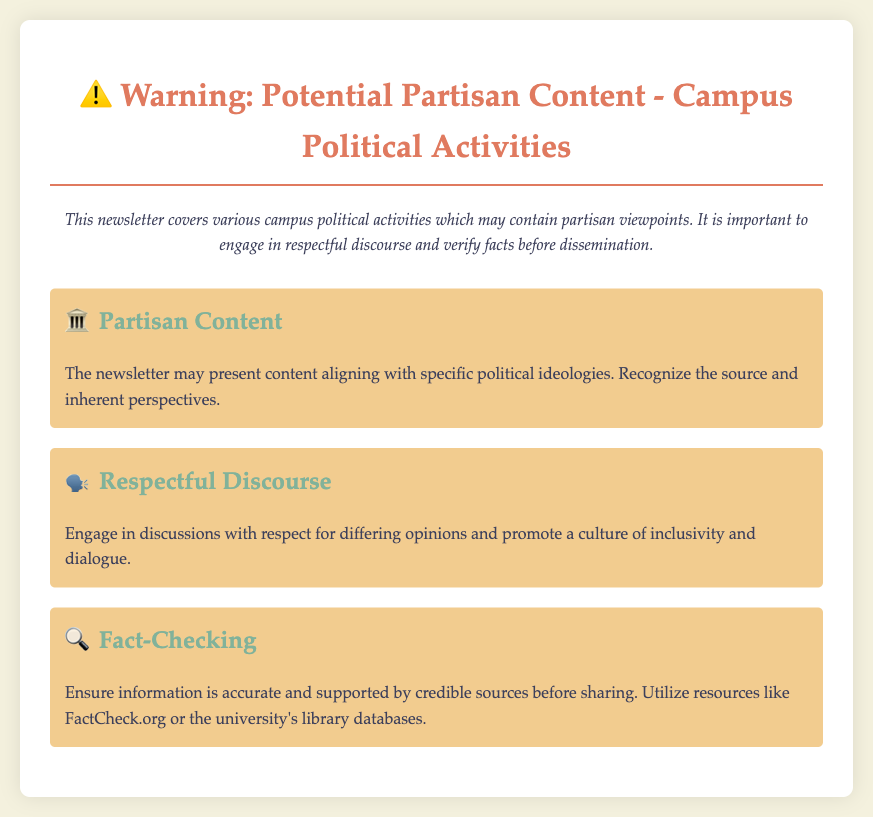What is the title of the document? The title is indicated at the beginning of the document within the `<h1>` tag.
Answer: Warning: Potential Partisan Content - Campus Political Activities What does the description highlight? The description provides an overview of the newsletter's content and its implications concerning political viewpoints.
Answer: Potential partisan viewpoints What icon is used to represent Partisan Content? The icon details are specified in the associated `<h2>` section of the document.
Answer: 🏛️ How many sections are in the document? The number of sections can be counted from the main content area in the document.
Answer: Three What should one verify before dissemination? The content advises on a specific action to take regarding information shared from the newsletter.
Answer: Facts What does the section on Respectful Discourse emphasize? This section focuses on the manner of engagement in discussions among differing opinions.
Answer: Respect Which resource is suggested for fact-checking? The document specifies resources in the fact-checking section.
Answer: FactCheck.org What color is used for the main heading? The heading color is denoted in the CSS styles for the document.
Answer: #e07a5f What is the background color of the main container? The background color of the main container is defined within the CSS styles.
Answer: #fff 